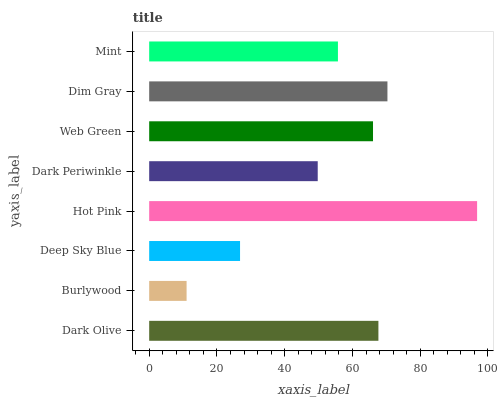Is Burlywood the minimum?
Answer yes or no. Yes. Is Hot Pink the maximum?
Answer yes or no. Yes. Is Deep Sky Blue the minimum?
Answer yes or no. No. Is Deep Sky Blue the maximum?
Answer yes or no. No. Is Deep Sky Blue greater than Burlywood?
Answer yes or no. Yes. Is Burlywood less than Deep Sky Blue?
Answer yes or no. Yes. Is Burlywood greater than Deep Sky Blue?
Answer yes or no. No. Is Deep Sky Blue less than Burlywood?
Answer yes or no. No. Is Web Green the high median?
Answer yes or no. Yes. Is Mint the low median?
Answer yes or no. Yes. Is Deep Sky Blue the high median?
Answer yes or no. No. Is Dark Olive the low median?
Answer yes or no. No. 